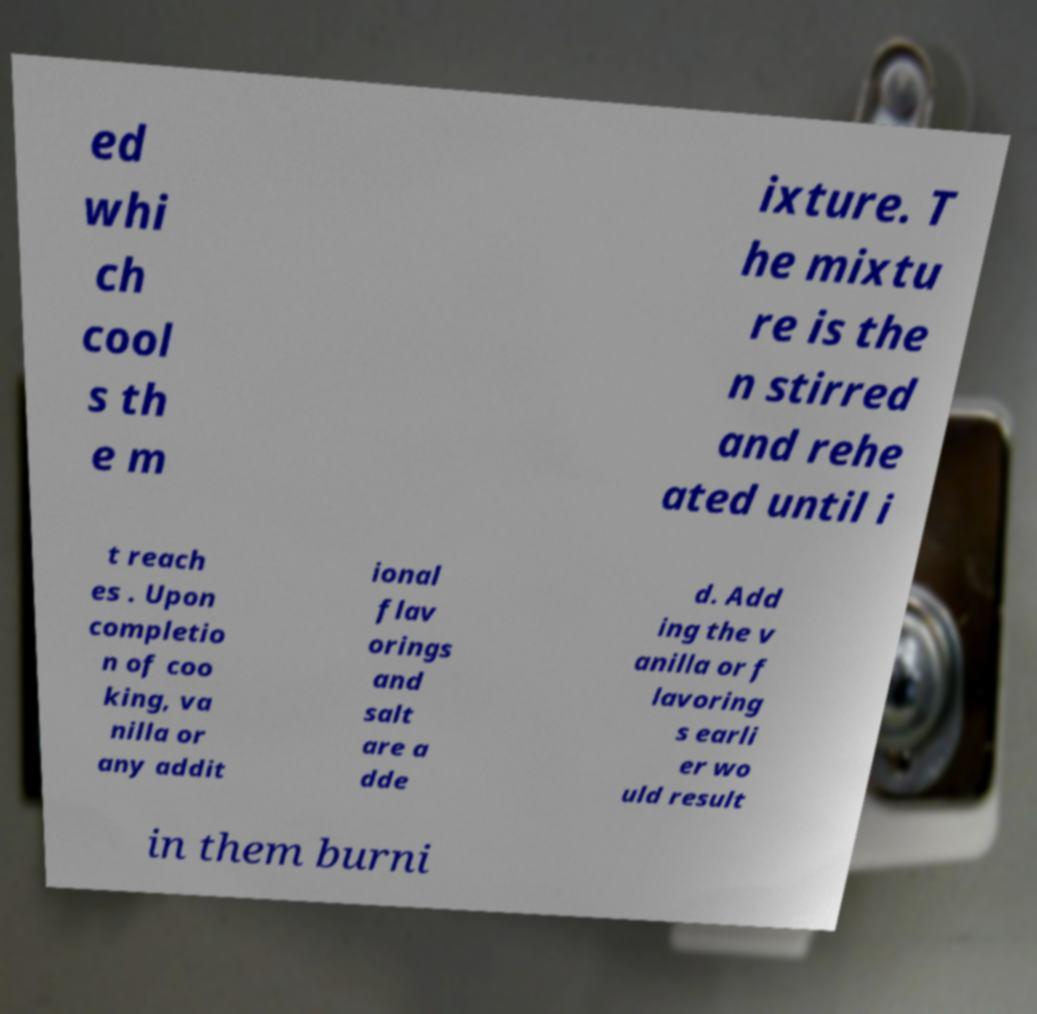Can you read and provide the text displayed in the image?This photo seems to have some interesting text. Can you extract and type it out for me? ed whi ch cool s th e m ixture. T he mixtu re is the n stirred and rehe ated until i t reach es . Upon completio n of coo king, va nilla or any addit ional flav orings and salt are a dde d. Add ing the v anilla or f lavoring s earli er wo uld result in them burni 